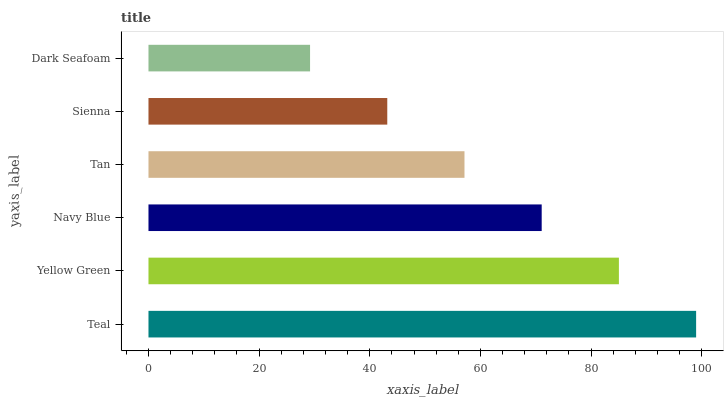Is Dark Seafoam the minimum?
Answer yes or no. Yes. Is Teal the maximum?
Answer yes or no. Yes. Is Yellow Green the minimum?
Answer yes or no. No. Is Yellow Green the maximum?
Answer yes or no. No. Is Teal greater than Yellow Green?
Answer yes or no. Yes. Is Yellow Green less than Teal?
Answer yes or no. Yes. Is Yellow Green greater than Teal?
Answer yes or no. No. Is Teal less than Yellow Green?
Answer yes or no. No. Is Navy Blue the high median?
Answer yes or no. Yes. Is Tan the low median?
Answer yes or no. Yes. Is Dark Seafoam the high median?
Answer yes or no. No. Is Yellow Green the low median?
Answer yes or no. No. 